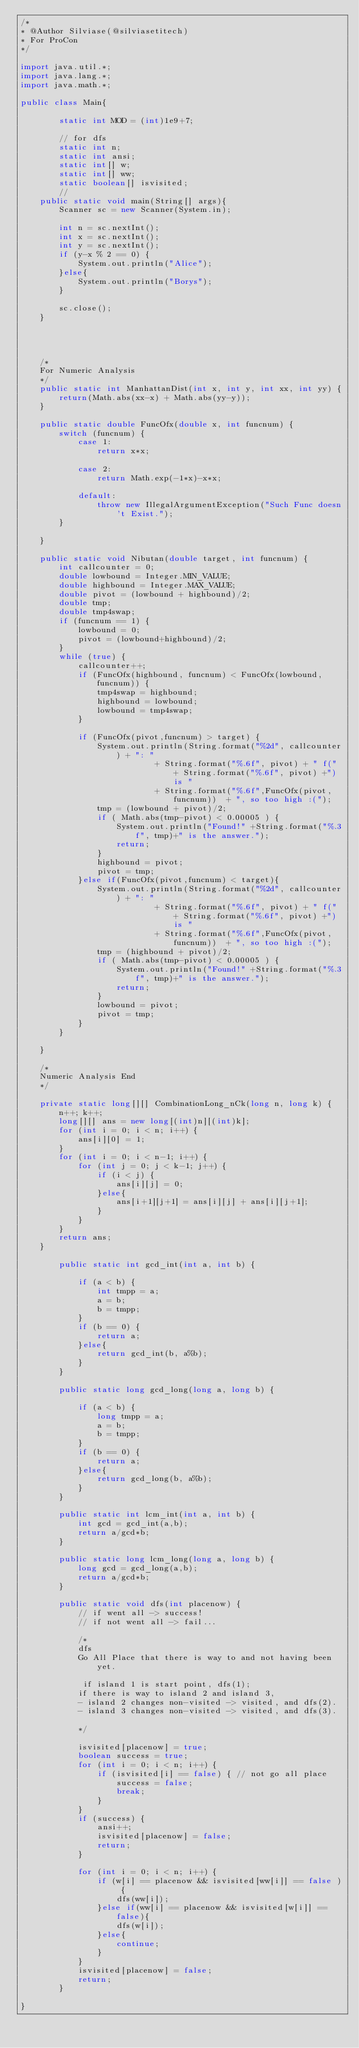<code> <loc_0><loc_0><loc_500><loc_500><_Java_>/*
* @Author Silviase(@silviasetitech)
* For ProCon
*/

import java.util.*;
import java.lang.*;
import java.math.*;

public class Main{

        static int MOD = (int)1e9+7;

        // for dfs
        static int n;
        static int ansi;
        static int[] w;
        static int[] ww;
        static boolean[] isvisited;
        //
    public static void main(String[] args){
        Scanner sc = new Scanner(System.in);

        int n = sc.nextInt();
        int x = sc.nextInt();
        int y = sc.nextInt();
        if (y-x % 2 == 0) {
            System.out.println("Alice");
        }else{
            System.out.println("Borys");
        }

        sc.close();
    }

    


    /*
    For Numeric Analysis
    */
    public static int ManhattanDist(int x, int y, int xx, int yy) {
        return(Math.abs(xx-x) + Math.abs(yy-y));
    }

    public static double FuncOfx(double x, int funcnum) {
        switch (funcnum) {
            case 1:
                return x*x;

            case 2:
                return Math.exp(-1*x)-x*x;
        
            default:
                throw new IllegalArgumentException("Such Func doesn't Exist.");
        }
            
    }

    public static void Nibutan(double target, int funcnum) {
        int callcounter = 0;
        double lowbound = Integer.MIN_VALUE;
        double highbound = Integer.MAX_VALUE;
        double pivot = (lowbound + highbound)/2;
        double tmp;
        double tmp4swap;
        if (funcnum == 1) {
            lowbound = 0;
            pivot = (lowbound+highbound)/2;
        }
        while (true) {
            callcounter++;
            if (FuncOfx(highbound, funcnum) < FuncOfx(lowbound, funcnum)) {
                tmp4swap = highbound;
                highbound = lowbound;
                lowbound = tmp4swap;
            }

            if (FuncOfx(pivot,funcnum) > target) {
                System.out.println(String.format("%2d", callcounter) + ": " 
                            + String.format("%.6f", pivot) + " f(" + String.format("%.6f", pivot) +") is " 
                            + String.format("%.6f",FuncOfx(pivot,funcnum))  + ", so too high :(");
                tmp = (lowbound + pivot)/2;
                if ( Math.abs(tmp-pivot) < 0.00005 ) {
                    System.out.println("Found!" +String.format("%.3f", tmp)+" is the answer.");
                    return;
                }
                highbound = pivot;
                pivot = tmp;
            }else if(FuncOfx(pivot,funcnum) < target){
                System.out.println(String.format("%2d", callcounter) + ": " 
                            + String.format("%.6f", pivot) + " f(" + String.format("%.6f", pivot) +") is " 
                            + String.format("%.6f",FuncOfx(pivot,funcnum))  + ", so too high :(");
                tmp = (highbound + pivot)/2;
                if ( Math.abs(tmp-pivot) < 0.00005 ) {
                    System.out.println("Found!" +String.format("%.3f", tmp)+" is the answer.");
                    return;
                }
                lowbound = pivot;
                pivot = tmp;
            }
        }
        
    }

    /*
    Numeric Analysis End
    */

    private static long[][] CombinationLong_nCk(long n, long k) {
        n++; k++;
        long[][] ans = new long[(int)n][(int)k];
        for (int i = 0; i < n; i++) {
            ans[i][0] = 1;
        }
        for (int i = 0; i < n-1; i++) {
            for (int j = 0; j < k-1; j++) {
                if (i < j) {
                    ans[i][j] = 0;
                }else{
                    ans[i+1][j+1] = ans[i][j] + ans[i][j+1];
                }
            }
        }
        return ans;
    }

        public static int gcd_int(int a, int b) {
        
            if (a < b) {
                int tmpp = a;
                a = b;
                b = tmpp;
            }
            if (b == 0) {
                return a;
            }else{
                return gcd_int(b, a%b);
            }
        } 

        public static long gcd_long(long a, long b) {
        
            if (a < b) {
                long tmpp = a;
                a = b;
                b = tmpp;
            }
            if (b == 0) {
                return a;
            }else{
                return gcd_long(b, a%b);
            }
        }

        public static int lcm_int(int a, int b) {
            int gcd = gcd_int(a,b);
            return a/gcd*b;
        }

        public static long lcm_long(long a, long b) {
            long gcd = gcd_long(a,b);
            return a/gcd*b;
        }

        public static void dfs(int placenow) {
            // if went all -> success! 
            // if not went all -> fail...
            
            /*
            dfs    
            Go All Place that there is way to and not having been yet. 

             if island 1 is start point, dfs(1);
            if there is way to island 2 and island 3,
            - island 2 changes non-visited -> visited, and dfs(2).
            - island 3 changes non-visited -> visited, and dfs(3).
    
            */

            isvisited[placenow] = true;
            boolean success = true;
            for (int i = 0; i < n; i++) {
                if (isvisited[i] == false) { // not go all place
                    success = false;
                    break;
                }
            }
            if (success) {
                ansi++;
                isvisited[placenow] = false;
                return;
            }

            for (int i = 0; i < n; i++) {
                if (w[i] == placenow && isvisited[ww[i]] == false ) {
                    dfs(ww[i]);
                }else if(ww[i] == placenow && isvisited[w[i]] == false){
                    dfs(w[i]);
                }else{
                    continue;
                }
            }
            isvisited[placenow] = false;
            return;
        }

}

</code> 